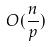Convert formula to latex. <formula><loc_0><loc_0><loc_500><loc_500>O ( \frac { n } { p } )</formula> 